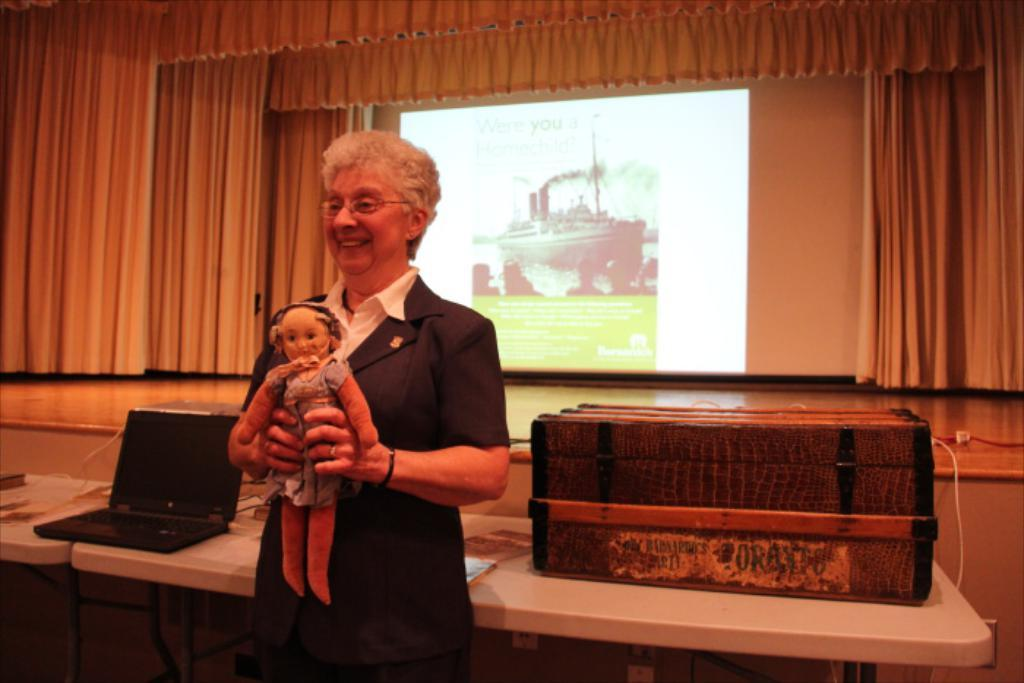What type of area is depicted in the image? There is a stage in the image. What is another feature of the image related to visual presentation? There is a projector screen in the image. What type of decorative element can be seen in the image? There are curtains in the image. What is present on the stage in the image that might be used for displaying items? There are objects placed on a table in the image. Who is in the image, and what is she doing? A lady is standing in the image, and she is holding a toy. What type of competition is taking place on the stage in the image? There is no competition taking place on the stage in the image; it simply shows a lady holding a toy. Can you see a yoke being used by the lady in the image? There is no yoke present in the image. 